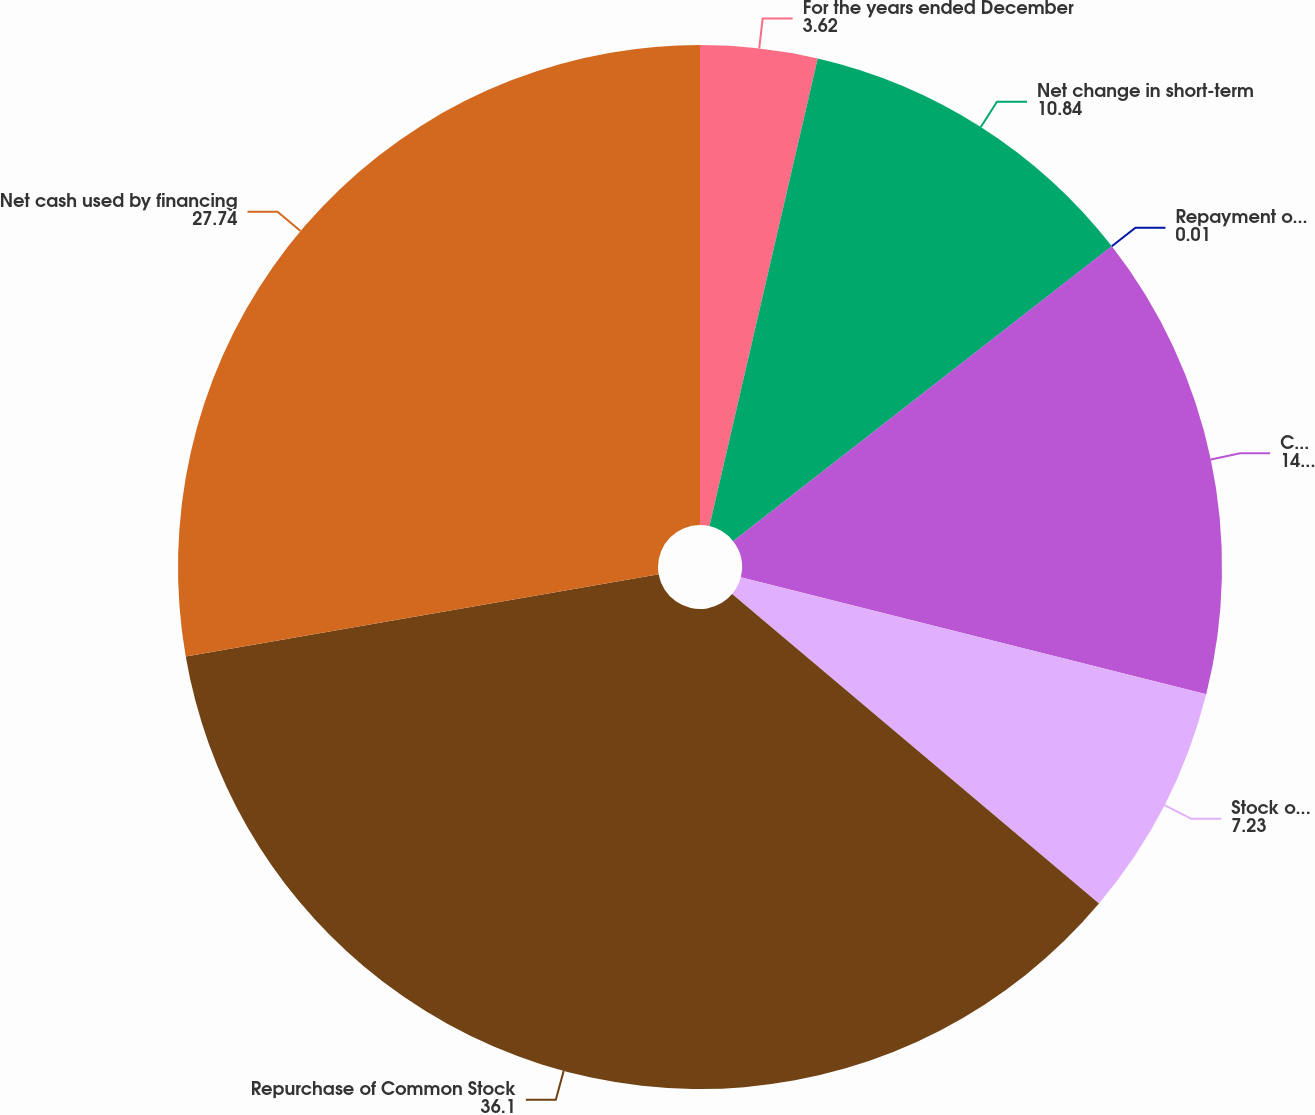Convert chart to OTSL. <chart><loc_0><loc_0><loc_500><loc_500><pie_chart><fcel>For the years ended December<fcel>Net change in short-term<fcel>Repayment of long-term debt<fcel>Cash dividends paid<fcel>Stock options exercises<fcel>Repurchase of Common Stock<fcel>Net cash used by financing<nl><fcel>3.62%<fcel>10.84%<fcel>0.01%<fcel>14.45%<fcel>7.23%<fcel>36.1%<fcel>27.74%<nl></chart> 